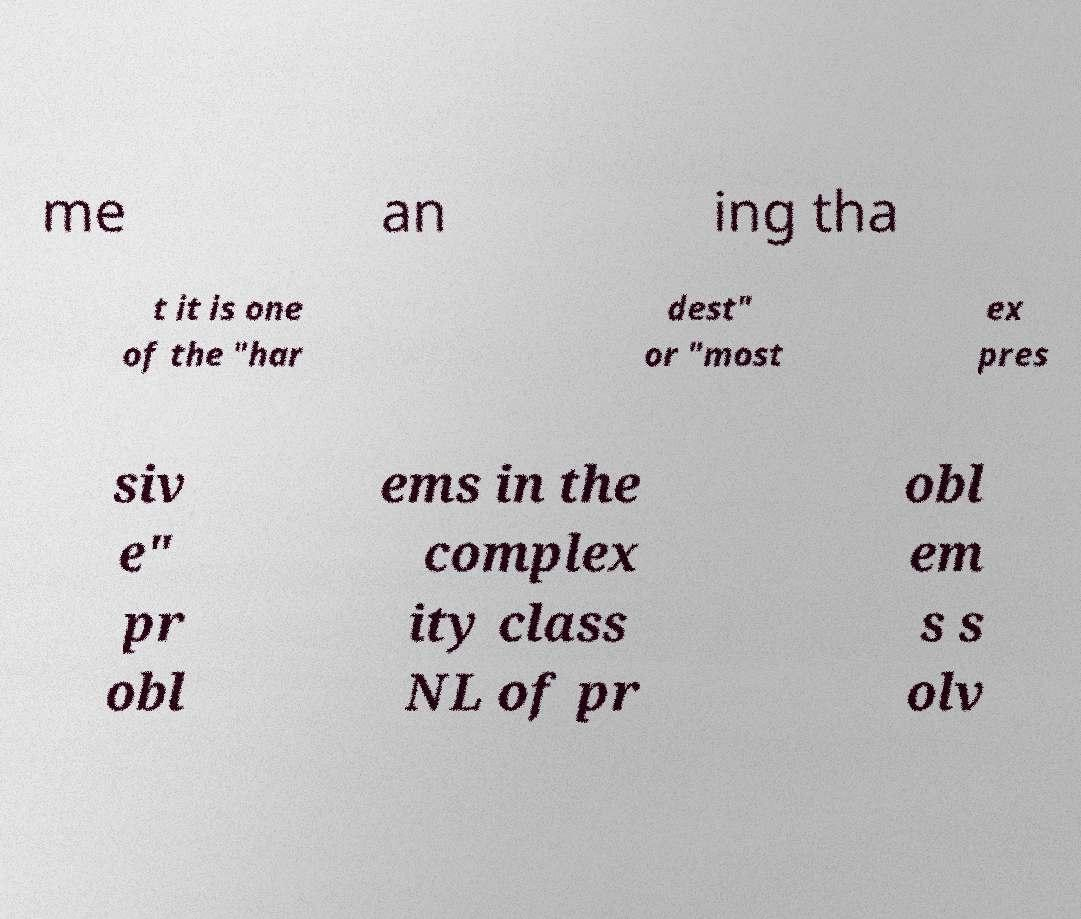There's text embedded in this image that I need extracted. Can you transcribe it verbatim? me an ing tha t it is one of the "har dest" or "most ex pres siv e" pr obl ems in the complex ity class NL of pr obl em s s olv 